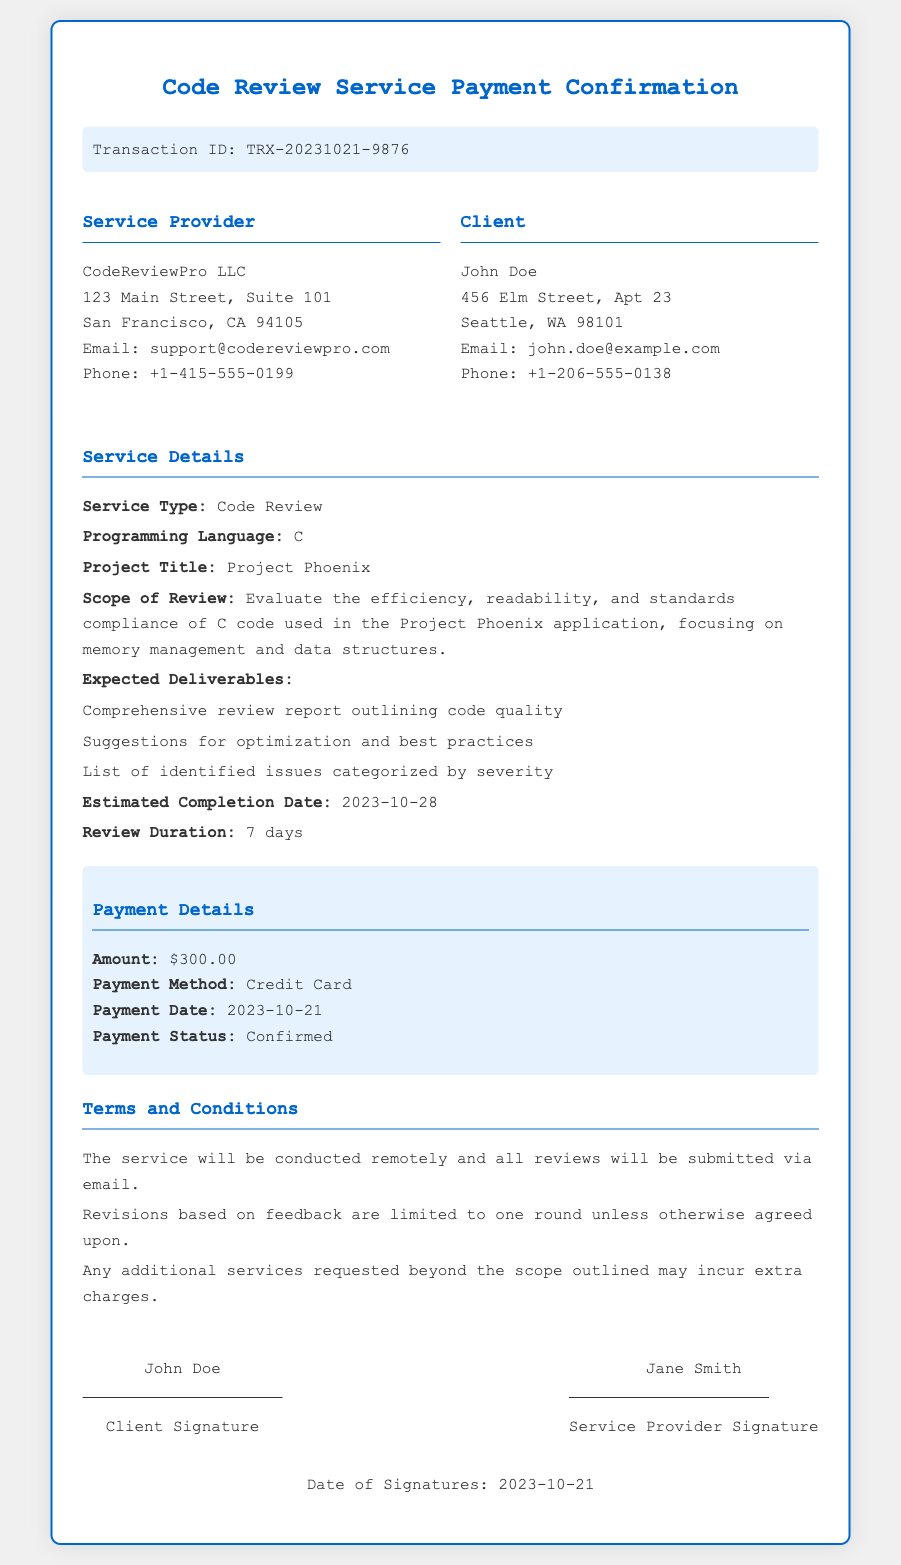What is the transaction ID? The transaction ID is explicitly stated in the document.
Answer: TRX-20231021-9876 What is the client’s email address? The email address for the client, John Doe, is provided in the document.
Answer: john.doe@example.com What is the payment amount? The amount paid for the service is clearly specified in the payment details section.
Answer: $300.00 When is the estimated completion date? The document includes the estimated completion date in the service details.
Answer: 2023-10-28 What is the scope of the review? The detailed scope of the review is outlined in the service details section.
Answer: Evaluate the efficiency, readability, and standards compliance of C code used in the Project Phoenix application, focusing on memory management and data structures What are the expected deliverables? The document lists the expected deliverables under service details.
Answer: Comprehensive review report outlining code quality, Suggestions for optimization and best practices, List of identified issues categorized by severity How long is the review duration? The review duration is mentioned in the service details section.
Answer: 7 days Who signs as the service provider? The document specifies who has signed as the service provider in the signature section.
Answer: Jane Smith 